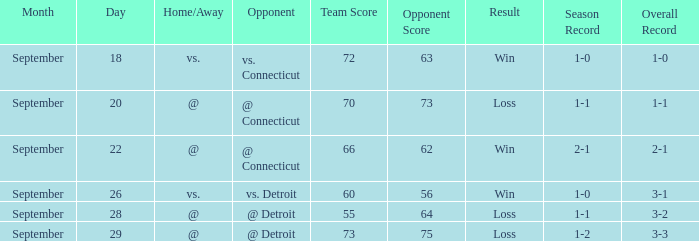WHAT IS THE RESULT WITH A SCORE OF 70-73? Loss. 